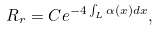Convert formula to latex. <formula><loc_0><loc_0><loc_500><loc_500>R _ { r } = C e ^ { - 4 \int _ { L } \alpha ( x ) d x } ,</formula> 